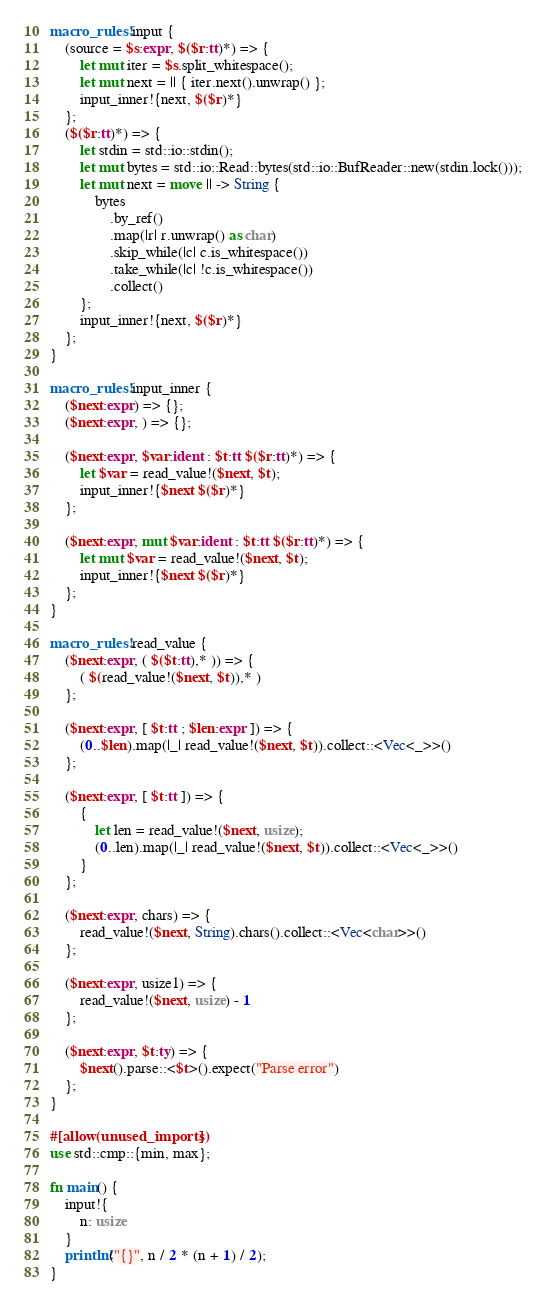Convert code to text. <code><loc_0><loc_0><loc_500><loc_500><_Rust_>macro_rules! input {
    (source = $s:expr, $($r:tt)*) => {
        let mut iter = $s.split_whitespace();
        let mut next = || { iter.next().unwrap() };
        input_inner!{next, $($r)*}
    };
    ($($r:tt)*) => {
        let stdin = std::io::stdin();
        let mut bytes = std::io::Read::bytes(std::io::BufReader::new(stdin.lock()));
        let mut next = move || -> String {
            bytes
                .by_ref()
                .map(|r| r.unwrap() as char)
                .skip_while(|c| c.is_whitespace())
                .take_while(|c| !c.is_whitespace())
                .collect()
        };
        input_inner!{next, $($r)*}
    };
}

macro_rules! input_inner {
    ($next:expr) => {};
    ($next:expr, ) => {};

    ($next:expr, $var:ident : $t:tt $($r:tt)*) => {
        let $var = read_value!($next, $t);
        input_inner!{$next $($r)*}
    };

    ($next:expr, mut $var:ident : $t:tt $($r:tt)*) => {
        let mut $var = read_value!($next, $t);
        input_inner!{$next $($r)*}
    };
}

macro_rules! read_value {
    ($next:expr, ( $($t:tt),* )) => {
        ( $(read_value!($next, $t)),* )
    };

    ($next:expr, [ $t:tt ; $len:expr ]) => {
        (0..$len).map(|_| read_value!($next, $t)).collect::<Vec<_>>()
    };

    ($next:expr, [ $t:tt ]) => {
        {
            let len = read_value!($next, usize);
            (0..len).map(|_| read_value!($next, $t)).collect::<Vec<_>>()
        }
    };

    ($next:expr, chars) => {
        read_value!($next, String).chars().collect::<Vec<char>>()
    };

    ($next:expr, usize1) => {
        read_value!($next, usize) - 1
    };

    ($next:expr, $t:ty) => {
        $next().parse::<$t>().expect("Parse error")
    };
}

#[allow(unused_imports)]
use std::cmp::{min, max};

fn main() {
    input!{
        n: usize
    }
    println!("{}", n / 2 * (n + 1) / 2);
}
</code> 